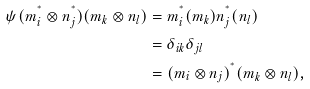Convert formula to latex. <formula><loc_0><loc_0><loc_500><loc_500>\psi ( m _ { i } ^ { ^ { * } } \otimes n _ { j } ^ { ^ { * } } ) ( m _ { k } \otimes n _ { l } ) & = m _ { i } ^ { ^ { * } } ( m _ { k } ) n _ { j } ^ { ^ { * } } ( n _ { l } ) \\ & = \delta _ { i k } \delta _ { j l } \\ & = ( m _ { i } \otimes n _ { j } ) ^ { ^ { * } } ( m _ { k } \otimes n _ { l } ) ,</formula> 